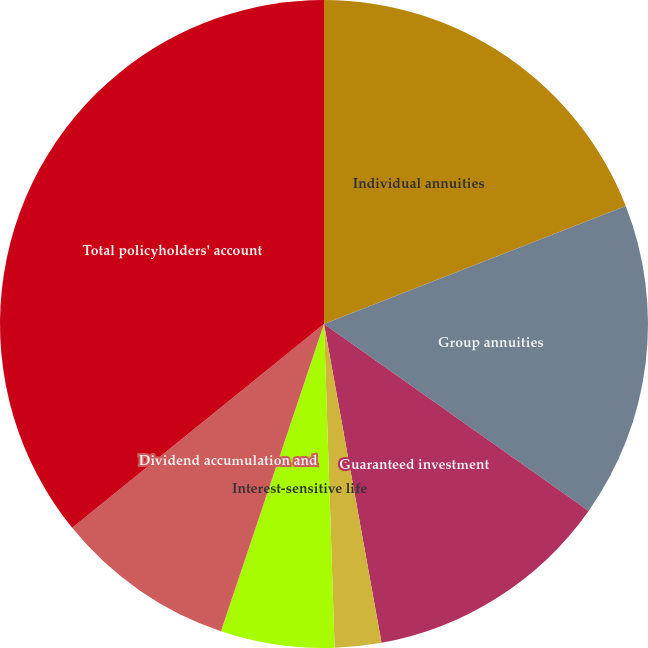Convert chart to OTSL. <chart><loc_0><loc_0><loc_500><loc_500><pie_chart><fcel>Individual annuities<fcel>Group annuities<fcel>Guaranteed investment<fcel>Funding agreements<fcel>Interest-sensitive life<fcel>Dividend accumulation and<fcel>Total policyholders' account<nl><fcel>19.07%<fcel>15.72%<fcel>12.37%<fcel>2.32%<fcel>5.67%<fcel>9.02%<fcel>35.83%<nl></chart> 